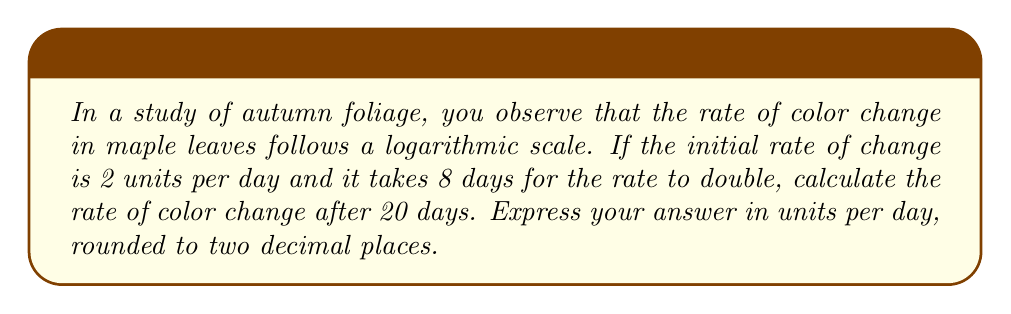Can you solve this math problem? Let's approach this step-by-step using the properties of logarithmic growth:

1) The general equation for logarithmic growth is:
   $$ y = a \log_b(x) + c $$
   where $a$ is the growth factor, $b$ is the base, and $c$ is the initial value.

2) We know that it takes 8 days for the rate to double. This means:
   $$ 2 = 2^{\frac{8}{t}} $$
   where $t$ is the time it takes for the rate to increase by a factor of $e$.

3) Solving for $t$:
   $$ \log_2(2) = \frac{8}{t} $$
   $$ 1 = \frac{8}{t} $$
   $$ t = 8 $$

4) Now we can write our equation:
   $$ r = 2 \cdot e^{\frac{\ln(2)}{8}t} $$
   where $r$ is the rate and $t$ is time in days.

5) To find the rate after 20 days, we substitute $t = 20$:
   $$ r = 2 \cdot e^{\frac{\ln(2)}{8} \cdot 20} $$
   $$ r = 2 \cdot e^{\frac{20\ln(2)}{8}} $$
   $$ r = 2 \cdot e^{2.5\ln(2)} $$
   $$ r = 2 \cdot 2^{2.5} $$
   $$ r = 2 \cdot 5.6568... $$
   $$ r = 11.3137... $$

6) Rounding to two decimal places:
   $$ r \approx 11.31 $$
Answer: 11.31 units per day 